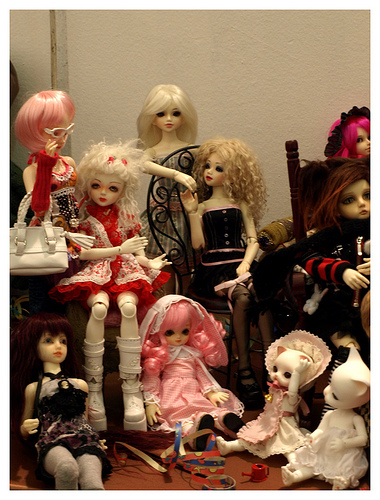<image>
Is there a hand one above the hand two? Yes. The hand one is positioned above the hand two in the vertical space, higher up in the scene. 